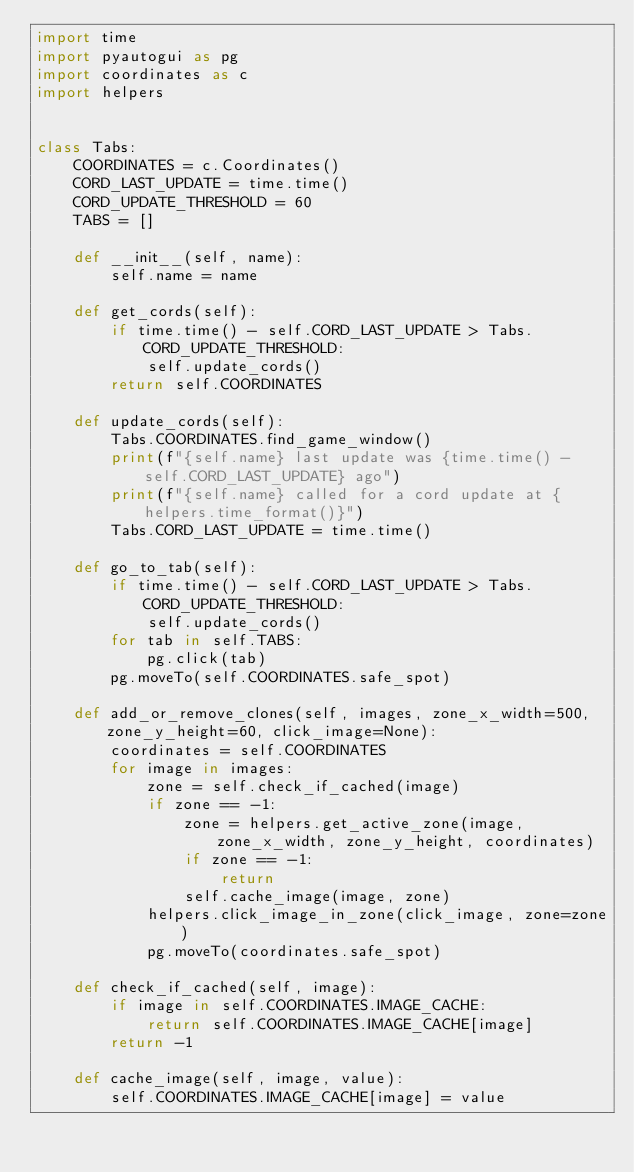<code> <loc_0><loc_0><loc_500><loc_500><_Python_>import time
import pyautogui as pg
import coordinates as c
import helpers


class Tabs:
    COORDINATES = c.Coordinates()
    CORD_LAST_UPDATE = time.time()
    CORD_UPDATE_THRESHOLD = 60
    TABS = []

    def __init__(self, name):
        self.name = name

    def get_cords(self):
        if time.time() - self.CORD_LAST_UPDATE > Tabs.CORD_UPDATE_THRESHOLD:
            self.update_cords()
        return self.COORDINATES

    def update_cords(self):
        Tabs.COORDINATES.find_game_window()
        print(f"{self.name} last update was {time.time() - self.CORD_LAST_UPDATE} ago")
        print(f"{self.name} called for a cord update at {helpers.time_format()}")
        Tabs.CORD_LAST_UPDATE = time.time()

    def go_to_tab(self):
        if time.time() - self.CORD_LAST_UPDATE > Tabs.CORD_UPDATE_THRESHOLD:
            self.update_cords()
        for tab in self.TABS:
            pg.click(tab)
        pg.moveTo(self.COORDINATES.safe_spot)

    def add_or_remove_clones(self, images, zone_x_width=500, zone_y_height=60, click_image=None):
        coordinates = self.COORDINATES
        for image in images:
            zone = self.check_if_cached(image)
            if zone == -1:
                zone = helpers.get_active_zone(image, zone_x_width, zone_y_height, coordinates)
                if zone == -1:
                    return
                self.cache_image(image, zone)
            helpers.click_image_in_zone(click_image, zone=zone)
            pg.moveTo(coordinates.safe_spot)

    def check_if_cached(self, image):
        if image in self.COORDINATES.IMAGE_CACHE:
            return self.COORDINATES.IMAGE_CACHE[image]
        return -1

    def cache_image(self, image, value):
        self.COORDINATES.IMAGE_CACHE[image] = value
</code> 